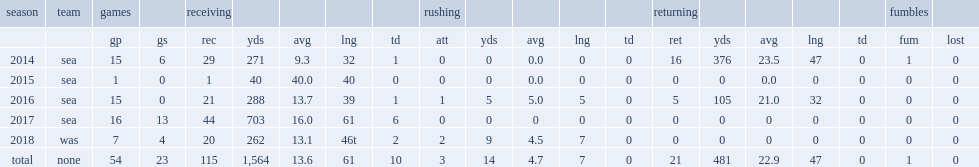How many receptions did richardson get in 2014? 29.0. Write the full table. {'header': ['season', 'team', 'games', '', 'receiving', '', '', '', '', 'rushing', '', '', '', '', 'returning', '', '', '', '', 'fumbles', ''], 'rows': [['', '', 'gp', 'gs', 'rec', 'yds', 'avg', 'lng', 'td', 'att', 'yds', 'avg', 'lng', 'td', 'ret', 'yds', 'avg', 'lng', 'td', 'fum', 'lost'], ['2014', 'sea', '15', '6', '29', '271', '9.3', '32', '1', '0', '0', '0.0', '0', '0', '16', '376', '23.5', '47', '0', '1', '0'], ['2015', 'sea', '1', '0', '1', '40', '40.0', '40', '0', '0', '0', '0.0', '0', '0', '0', '0', '0.0', '0', '0', '0', '0'], ['2016', 'sea', '15', '0', '21', '288', '13.7', '39', '1', '1', '5', '5.0', '5', '0', '5', '105', '21.0', '32', '0', '0', '0'], ['2017', 'sea', '16', '13', '44', '703', '16.0', '61', '6', '0', '0', '0', '0', '0', '0', '0', '0', '0', '0', '0', '0'], ['2018', 'was', '7', '4', '20', '262', '13.1', '46t', '2', '2', '9', '4.5', '7', '0', '0', '0', '0', '0', '0', '0', '0'], ['total', 'none', '54', '23', '115', '1,564', '13.6', '61', '10', '3', '14', '4.7', '7', '0', '21', '481', '22.9', '47', '0', '1', '0']]} 